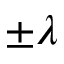Convert formula to latex. <formula><loc_0><loc_0><loc_500><loc_500>\pm \lambda</formula> 